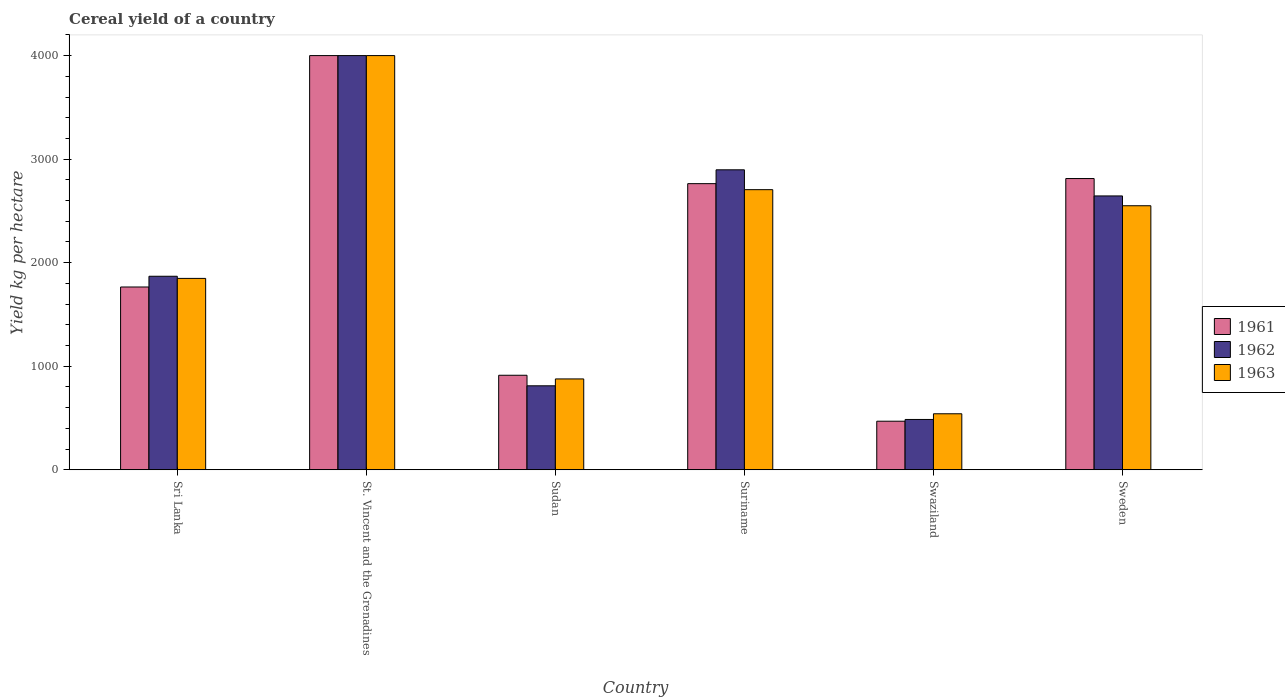How many different coloured bars are there?
Ensure brevity in your answer.  3. Are the number of bars on each tick of the X-axis equal?
Your response must be concise. Yes. How many bars are there on the 1st tick from the left?
Provide a short and direct response. 3. How many bars are there on the 1st tick from the right?
Make the answer very short. 3. What is the label of the 1st group of bars from the left?
Your answer should be compact. Sri Lanka. What is the total cereal yield in 1963 in Sudan?
Your answer should be very brief. 877.56. Across all countries, what is the maximum total cereal yield in 1962?
Provide a short and direct response. 4000. Across all countries, what is the minimum total cereal yield in 1963?
Provide a short and direct response. 541.11. In which country was the total cereal yield in 1962 maximum?
Give a very brief answer. St. Vincent and the Grenadines. In which country was the total cereal yield in 1962 minimum?
Your response must be concise. Swaziland. What is the total total cereal yield in 1961 in the graph?
Your response must be concise. 1.27e+04. What is the difference between the total cereal yield in 1961 in Sri Lanka and that in Suriname?
Offer a terse response. -997.93. What is the difference between the total cereal yield in 1963 in Sudan and the total cereal yield in 1962 in Sweden?
Your answer should be very brief. -1767.12. What is the average total cereal yield in 1963 per country?
Offer a terse response. 2087.06. What is the difference between the total cereal yield of/in 1961 and total cereal yield of/in 1962 in Suriname?
Ensure brevity in your answer.  -133.64. In how many countries, is the total cereal yield in 1961 greater than 3200 kg per hectare?
Ensure brevity in your answer.  1. What is the ratio of the total cereal yield in 1961 in Sri Lanka to that in Suriname?
Your answer should be very brief. 0.64. What is the difference between the highest and the second highest total cereal yield in 1963?
Ensure brevity in your answer.  1294.69. What is the difference between the highest and the lowest total cereal yield in 1963?
Offer a terse response. 3458.89. In how many countries, is the total cereal yield in 1963 greater than the average total cereal yield in 1963 taken over all countries?
Your response must be concise. 3. What does the 3rd bar from the right in Sweden represents?
Keep it short and to the point. 1961. Are the values on the major ticks of Y-axis written in scientific E-notation?
Ensure brevity in your answer.  No. Does the graph contain any zero values?
Your answer should be very brief. No. How many legend labels are there?
Provide a short and direct response. 3. What is the title of the graph?
Your answer should be very brief. Cereal yield of a country. Does "1964" appear as one of the legend labels in the graph?
Ensure brevity in your answer.  No. What is the label or title of the X-axis?
Provide a succinct answer. Country. What is the label or title of the Y-axis?
Offer a terse response. Yield kg per hectare. What is the Yield kg per hectare in 1961 in Sri Lanka?
Provide a succinct answer. 1765.43. What is the Yield kg per hectare of 1962 in Sri Lanka?
Make the answer very short. 1869.1. What is the Yield kg per hectare of 1963 in Sri Lanka?
Offer a terse response. 1848.43. What is the Yield kg per hectare in 1961 in St. Vincent and the Grenadines?
Make the answer very short. 4000. What is the Yield kg per hectare in 1962 in St. Vincent and the Grenadines?
Provide a succinct answer. 4000. What is the Yield kg per hectare in 1963 in St. Vincent and the Grenadines?
Your answer should be compact. 4000. What is the Yield kg per hectare in 1961 in Sudan?
Make the answer very short. 913.1. What is the Yield kg per hectare of 1962 in Sudan?
Your response must be concise. 811.23. What is the Yield kg per hectare of 1963 in Sudan?
Ensure brevity in your answer.  877.56. What is the Yield kg per hectare of 1961 in Suriname?
Make the answer very short. 2763.36. What is the Yield kg per hectare of 1962 in Suriname?
Make the answer very short. 2897.01. What is the Yield kg per hectare in 1963 in Suriname?
Provide a succinct answer. 2705.31. What is the Yield kg per hectare in 1961 in Swaziland?
Provide a succinct answer. 469.25. What is the Yield kg per hectare in 1962 in Swaziland?
Provide a short and direct response. 486.15. What is the Yield kg per hectare of 1963 in Swaziland?
Keep it short and to the point. 541.11. What is the Yield kg per hectare in 1961 in Sweden?
Provide a succinct answer. 2812.7. What is the Yield kg per hectare of 1962 in Sweden?
Give a very brief answer. 2644.68. What is the Yield kg per hectare of 1963 in Sweden?
Make the answer very short. 2549.97. Across all countries, what is the maximum Yield kg per hectare of 1961?
Provide a succinct answer. 4000. Across all countries, what is the maximum Yield kg per hectare in 1962?
Make the answer very short. 4000. Across all countries, what is the maximum Yield kg per hectare in 1963?
Offer a very short reply. 4000. Across all countries, what is the minimum Yield kg per hectare of 1961?
Give a very brief answer. 469.25. Across all countries, what is the minimum Yield kg per hectare in 1962?
Keep it short and to the point. 486.15. Across all countries, what is the minimum Yield kg per hectare of 1963?
Ensure brevity in your answer.  541.11. What is the total Yield kg per hectare in 1961 in the graph?
Offer a terse response. 1.27e+04. What is the total Yield kg per hectare of 1962 in the graph?
Give a very brief answer. 1.27e+04. What is the total Yield kg per hectare in 1963 in the graph?
Your answer should be compact. 1.25e+04. What is the difference between the Yield kg per hectare of 1961 in Sri Lanka and that in St. Vincent and the Grenadines?
Keep it short and to the point. -2234.57. What is the difference between the Yield kg per hectare of 1962 in Sri Lanka and that in St. Vincent and the Grenadines?
Ensure brevity in your answer.  -2130.9. What is the difference between the Yield kg per hectare in 1963 in Sri Lanka and that in St. Vincent and the Grenadines?
Provide a succinct answer. -2151.57. What is the difference between the Yield kg per hectare of 1961 in Sri Lanka and that in Sudan?
Provide a succinct answer. 852.33. What is the difference between the Yield kg per hectare in 1962 in Sri Lanka and that in Sudan?
Keep it short and to the point. 1057.88. What is the difference between the Yield kg per hectare of 1963 in Sri Lanka and that in Sudan?
Make the answer very short. 970.87. What is the difference between the Yield kg per hectare in 1961 in Sri Lanka and that in Suriname?
Offer a very short reply. -997.93. What is the difference between the Yield kg per hectare in 1962 in Sri Lanka and that in Suriname?
Offer a terse response. -1027.91. What is the difference between the Yield kg per hectare of 1963 in Sri Lanka and that in Suriname?
Your response must be concise. -856.88. What is the difference between the Yield kg per hectare of 1961 in Sri Lanka and that in Swaziland?
Give a very brief answer. 1296.18. What is the difference between the Yield kg per hectare in 1962 in Sri Lanka and that in Swaziland?
Offer a terse response. 1382.95. What is the difference between the Yield kg per hectare in 1963 in Sri Lanka and that in Swaziland?
Make the answer very short. 1307.32. What is the difference between the Yield kg per hectare of 1961 in Sri Lanka and that in Sweden?
Provide a succinct answer. -1047.27. What is the difference between the Yield kg per hectare in 1962 in Sri Lanka and that in Sweden?
Give a very brief answer. -775.58. What is the difference between the Yield kg per hectare in 1963 in Sri Lanka and that in Sweden?
Your response must be concise. -701.54. What is the difference between the Yield kg per hectare in 1961 in St. Vincent and the Grenadines and that in Sudan?
Provide a succinct answer. 3086.9. What is the difference between the Yield kg per hectare of 1962 in St. Vincent and the Grenadines and that in Sudan?
Keep it short and to the point. 3188.78. What is the difference between the Yield kg per hectare in 1963 in St. Vincent and the Grenadines and that in Sudan?
Offer a very short reply. 3122.44. What is the difference between the Yield kg per hectare in 1961 in St. Vincent and the Grenadines and that in Suriname?
Offer a terse response. 1236.64. What is the difference between the Yield kg per hectare in 1962 in St. Vincent and the Grenadines and that in Suriname?
Your answer should be compact. 1102.99. What is the difference between the Yield kg per hectare in 1963 in St. Vincent and the Grenadines and that in Suriname?
Give a very brief answer. 1294.69. What is the difference between the Yield kg per hectare in 1961 in St. Vincent and the Grenadines and that in Swaziland?
Your response must be concise. 3530.75. What is the difference between the Yield kg per hectare in 1962 in St. Vincent and the Grenadines and that in Swaziland?
Your answer should be very brief. 3513.85. What is the difference between the Yield kg per hectare of 1963 in St. Vincent and the Grenadines and that in Swaziland?
Your answer should be compact. 3458.89. What is the difference between the Yield kg per hectare in 1961 in St. Vincent and the Grenadines and that in Sweden?
Make the answer very short. 1187.31. What is the difference between the Yield kg per hectare in 1962 in St. Vincent and the Grenadines and that in Sweden?
Your answer should be compact. 1355.32. What is the difference between the Yield kg per hectare in 1963 in St. Vincent and the Grenadines and that in Sweden?
Keep it short and to the point. 1450.03. What is the difference between the Yield kg per hectare in 1961 in Sudan and that in Suriname?
Provide a short and direct response. -1850.27. What is the difference between the Yield kg per hectare of 1962 in Sudan and that in Suriname?
Provide a short and direct response. -2085.78. What is the difference between the Yield kg per hectare of 1963 in Sudan and that in Suriname?
Make the answer very short. -1827.75. What is the difference between the Yield kg per hectare of 1961 in Sudan and that in Swaziland?
Provide a succinct answer. 443.84. What is the difference between the Yield kg per hectare of 1962 in Sudan and that in Swaziland?
Offer a very short reply. 325.08. What is the difference between the Yield kg per hectare in 1963 in Sudan and that in Swaziland?
Provide a succinct answer. 336.45. What is the difference between the Yield kg per hectare of 1961 in Sudan and that in Sweden?
Your answer should be compact. -1899.6. What is the difference between the Yield kg per hectare of 1962 in Sudan and that in Sweden?
Make the answer very short. -1833.45. What is the difference between the Yield kg per hectare of 1963 in Sudan and that in Sweden?
Make the answer very short. -1672.41. What is the difference between the Yield kg per hectare in 1961 in Suriname and that in Swaziland?
Make the answer very short. 2294.11. What is the difference between the Yield kg per hectare of 1962 in Suriname and that in Swaziland?
Your answer should be very brief. 2410.86. What is the difference between the Yield kg per hectare of 1963 in Suriname and that in Swaziland?
Offer a terse response. 2164.2. What is the difference between the Yield kg per hectare in 1961 in Suriname and that in Sweden?
Ensure brevity in your answer.  -49.33. What is the difference between the Yield kg per hectare in 1962 in Suriname and that in Sweden?
Your answer should be compact. 252.33. What is the difference between the Yield kg per hectare of 1963 in Suriname and that in Sweden?
Your response must be concise. 155.34. What is the difference between the Yield kg per hectare in 1961 in Swaziland and that in Sweden?
Offer a very short reply. -2343.44. What is the difference between the Yield kg per hectare of 1962 in Swaziland and that in Sweden?
Provide a short and direct response. -2158.53. What is the difference between the Yield kg per hectare in 1963 in Swaziland and that in Sweden?
Keep it short and to the point. -2008.86. What is the difference between the Yield kg per hectare in 1961 in Sri Lanka and the Yield kg per hectare in 1962 in St. Vincent and the Grenadines?
Give a very brief answer. -2234.57. What is the difference between the Yield kg per hectare in 1961 in Sri Lanka and the Yield kg per hectare in 1963 in St. Vincent and the Grenadines?
Offer a very short reply. -2234.57. What is the difference between the Yield kg per hectare in 1962 in Sri Lanka and the Yield kg per hectare in 1963 in St. Vincent and the Grenadines?
Offer a terse response. -2130.9. What is the difference between the Yield kg per hectare in 1961 in Sri Lanka and the Yield kg per hectare in 1962 in Sudan?
Keep it short and to the point. 954.2. What is the difference between the Yield kg per hectare of 1961 in Sri Lanka and the Yield kg per hectare of 1963 in Sudan?
Your answer should be compact. 887.87. What is the difference between the Yield kg per hectare of 1962 in Sri Lanka and the Yield kg per hectare of 1963 in Sudan?
Provide a short and direct response. 991.54. What is the difference between the Yield kg per hectare of 1961 in Sri Lanka and the Yield kg per hectare of 1962 in Suriname?
Offer a terse response. -1131.58. What is the difference between the Yield kg per hectare in 1961 in Sri Lanka and the Yield kg per hectare in 1963 in Suriname?
Provide a short and direct response. -939.88. What is the difference between the Yield kg per hectare in 1962 in Sri Lanka and the Yield kg per hectare in 1963 in Suriname?
Keep it short and to the point. -836.21. What is the difference between the Yield kg per hectare of 1961 in Sri Lanka and the Yield kg per hectare of 1962 in Swaziland?
Provide a succinct answer. 1279.28. What is the difference between the Yield kg per hectare in 1961 in Sri Lanka and the Yield kg per hectare in 1963 in Swaziland?
Provide a succinct answer. 1224.32. What is the difference between the Yield kg per hectare in 1962 in Sri Lanka and the Yield kg per hectare in 1963 in Swaziland?
Your answer should be very brief. 1327.99. What is the difference between the Yield kg per hectare in 1961 in Sri Lanka and the Yield kg per hectare in 1962 in Sweden?
Provide a succinct answer. -879.25. What is the difference between the Yield kg per hectare in 1961 in Sri Lanka and the Yield kg per hectare in 1963 in Sweden?
Your answer should be very brief. -784.54. What is the difference between the Yield kg per hectare of 1962 in Sri Lanka and the Yield kg per hectare of 1963 in Sweden?
Offer a terse response. -680.87. What is the difference between the Yield kg per hectare of 1961 in St. Vincent and the Grenadines and the Yield kg per hectare of 1962 in Sudan?
Your answer should be very brief. 3188.78. What is the difference between the Yield kg per hectare of 1961 in St. Vincent and the Grenadines and the Yield kg per hectare of 1963 in Sudan?
Your answer should be compact. 3122.44. What is the difference between the Yield kg per hectare in 1962 in St. Vincent and the Grenadines and the Yield kg per hectare in 1963 in Sudan?
Offer a terse response. 3122.44. What is the difference between the Yield kg per hectare in 1961 in St. Vincent and the Grenadines and the Yield kg per hectare in 1962 in Suriname?
Provide a succinct answer. 1102.99. What is the difference between the Yield kg per hectare of 1961 in St. Vincent and the Grenadines and the Yield kg per hectare of 1963 in Suriname?
Ensure brevity in your answer.  1294.69. What is the difference between the Yield kg per hectare in 1962 in St. Vincent and the Grenadines and the Yield kg per hectare in 1963 in Suriname?
Provide a short and direct response. 1294.69. What is the difference between the Yield kg per hectare of 1961 in St. Vincent and the Grenadines and the Yield kg per hectare of 1962 in Swaziland?
Offer a terse response. 3513.85. What is the difference between the Yield kg per hectare in 1961 in St. Vincent and the Grenadines and the Yield kg per hectare in 1963 in Swaziland?
Provide a short and direct response. 3458.89. What is the difference between the Yield kg per hectare of 1962 in St. Vincent and the Grenadines and the Yield kg per hectare of 1963 in Swaziland?
Give a very brief answer. 3458.89. What is the difference between the Yield kg per hectare in 1961 in St. Vincent and the Grenadines and the Yield kg per hectare in 1962 in Sweden?
Your answer should be compact. 1355.32. What is the difference between the Yield kg per hectare in 1961 in St. Vincent and the Grenadines and the Yield kg per hectare in 1963 in Sweden?
Your answer should be compact. 1450.03. What is the difference between the Yield kg per hectare in 1962 in St. Vincent and the Grenadines and the Yield kg per hectare in 1963 in Sweden?
Your answer should be compact. 1450.03. What is the difference between the Yield kg per hectare of 1961 in Sudan and the Yield kg per hectare of 1962 in Suriname?
Offer a terse response. -1983.91. What is the difference between the Yield kg per hectare of 1961 in Sudan and the Yield kg per hectare of 1963 in Suriname?
Ensure brevity in your answer.  -1792.21. What is the difference between the Yield kg per hectare of 1962 in Sudan and the Yield kg per hectare of 1963 in Suriname?
Make the answer very short. -1894.09. What is the difference between the Yield kg per hectare in 1961 in Sudan and the Yield kg per hectare in 1962 in Swaziland?
Provide a short and direct response. 426.95. What is the difference between the Yield kg per hectare of 1961 in Sudan and the Yield kg per hectare of 1963 in Swaziland?
Your response must be concise. 371.98. What is the difference between the Yield kg per hectare of 1962 in Sudan and the Yield kg per hectare of 1963 in Swaziland?
Your response must be concise. 270.11. What is the difference between the Yield kg per hectare of 1961 in Sudan and the Yield kg per hectare of 1962 in Sweden?
Your answer should be compact. -1731.58. What is the difference between the Yield kg per hectare of 1961 in Sudan and the Yield kg per hectare of 1963 in Sweden?
Provide a short and direct response. -1636.88. What is the difference between the Yield kg per hectare of 1962 in Sudan and the Yield kg per hectare of 1963 in Sweden?
Your response must be concise. -1738.75. What is the difference between the Yield kg per hectare of 1961 in Suriname and the Yield kg per hectare of 1962 in Swaziland?
Give a very brief answer. 2277.22. What is the difference between the Yield kg per hectare in 1961 in Suriname and the Yield kg per hectare in 1963 in Swaziland?
Provide a short and direct response. 2222.25. What is the difference between the Yield kg per hectare in 1962 in Suriname and the Yield kg per hectare in 1963 in Swaziland?
Your response must be concise. 2355.89. What is the difference between the Yield kg per hectare of 1961 in Suriname and the Yield kg per hectare of 1962 in Sweden?
Offer a terse response. 118.69. What is the difference between the Yield kg per hectare in 1961 in Suriname and the Yield kg per hectare in 1963 in Sweden?
Provide a short and direct response. 213.39. What is the difference between the Yield kg per hectare of 1962 in Suriname and the Yield kg per hectare of 1963 in Sweden?
Your answer should be very brief. 347.04. What is the difference between the Yield kg per hectare in 1961 in Swaziland and the Yield kg per hectare in 1962 in Sweden?
Provide a short and direct response. -2175.43. What is the difference between the Yield kg per hectare in 1961 in Swaziland and the Yield kg per hectare in 1963 in Sweden?
Keep it short and to the point. -2080.72. What is the difference between the Yield kg per hectare in 1962 in Swaziland and the Yield kg per hectare in 1963 in Sweden?
Provide a succinct answer. -2063.82. What is the average Yield kg per hectare in 1961 per country?
Your answer should be compact. 2120.64. What is the average Yield kg per hectare of 1962 per country?
Give a very brief answer. 2118.03. What is the average Yield kg per hectare of 1963 per country?
Make the answer very short. 2087.06. What is the difference between the Yield kg per hectare in 1961 and Yield kg per hectare in 1962 in Sri Lanka?
Your response must be concise. -103.67. What is the difference between the Yield kg per hectare of 1961 and Yield kg per hectare of 1963 in Sri Lanka?
Your answer should be very brief. -83. What is the difference between the Yield kg per hectare of 1962 and Yield kg per hectare of 1963 in Sri Lanka?
Your response must be concise. 20.67. What is the difference between the Yield kg per hectare in 1961 and Yield kg per hectare in 1962 in St. Vincent and the Grenadines?
Keep it short and to the point. 0. What is the difference between the Yield kg per hectare of 1961 and Yield kg per hectare of 1963 in St. Vincent and the Grenadines?
Provide a short and direct response. 0. What is the difference between the Yield kg per hectare in 1961 and Yield kg per hectare in 1962 in Sudan?
Provide a short and direct response. 101.87. What is the difference between the Yield kg per hectare in 1961 and Yield kg per hectare in 1963 in Sudan?
Make the answer very short. 35.53. What is the difference between the Yield kg per hectare in 1962 and Yield kg per hectare in 1963 in Sudan?
Provide a succinct answer. -66.34. What is the difference between the Yield kg per hectare of 1961 and Yield kg per hectare of 1962 in Suriname?
Your answer should be compact. -133.64. What is the difference between the Yield kg per hectare in 1961 and Yield kg per hectare in 1963 in Suriname?
Give a very brief answer. 58.05. What is the difference between the Yield kg per hectare of 1962 and Yield kg per hectare of 1963 in Suriname?
Make the answer very short. 191.7. What is the difference between the Yield kg per hectare in 1961 and Yield kg per hectare in 1962 in Swaziland?
Give a very brief answer. -16.9. What is the difference between the Yield kg per hectare in 1961 and Yield kg per hectare in 1963 in Swaziland?
Make the answer very short. -71.86. What is the difference between the Yield kg per hectare of 1962 and Yield kg per hectare of 1963 in Swaziland?
Make the answer very short. -54.97. What is the difference between the Yield kg per hectare in 1961 and Yield kg per hectare in 1962 in Sweden?
Your answer should be compact. 168.02. What is the difference between the Yield kg per hectare of 1961 and Yield kg per hectare of 1963 in Sweden?
Your answer should be compact. 262.72. What is the difference between the Yield kg per hectare in 1962 and Yield kg per hectare in 1963 in Sweden?
Offer a terse response. 94.71. What is the ratio of the Yield kg per hectare in 1961 in Sri Lanka to that in St. Vincent and the Grenadines?
Give a very brief answer. 0.44. What is the ratio of the Yield kg per hectare of 1962 in Sri Lanka to that in St. Vincent and the Grenadines?
Your answer should be very brief. 0.47. What is the ratio of the Yield kg per hectare in 1963 in Sri Lanka to that in St. Vincent and the Grenadines?
Give a very brief answer. 0.46. What is the ratio of the Yield kg per hectare of 1961 in Sri Lanka to that in Sudan?
Keep it short and to the point. 1.93. What is the ratio of the Yield kg per hectare in 1962 in Sri Lanka to that in Sudan?
Make the answer very short. 2.3. What is the ratio of the Yield kg per hectare in 1963 in Sri Lanka to that in Sudan?
Offer a terse response. 2.11. What is the ratio of the Yield kg per hectare in 1961 in Sri Lanka to that in Suriname?
Your answer should be very brief. 0.64. What is the ratio of the Yield kg per hectare of 1962 in Sri Lanka to that in Suriname?
Offer a very short reply. 0.65. What is the ratio of the Yield kg per hectare in 1963 in Sri Lanka to that in Suriname?
Offer a terse response. 0.68. What is the ratio of the Yield kg per hectare in 1961 in Sri Lanka to that in Swaziland?
Your answer should be compact. 3.76. What is the ratio of the Yield kg per hectare in 1962 in Sri Lanka to that in Swaziland?
Offer a very short reply. 3.84. What is the ratio of the Yield kg per hectare of 1963 in Sri Lanka to that in Swaziland?
Provide a short and direct response. 3.42. What is the ratio of the Yield kg per hectare in 1961 in Sri Lanka to that in Sweden?
Your response must be concise. 0.63. What is the ratio of the Yield kg per hectare in 1962 in Sri Lanka to that in Sweden?
Your answer should be very brief. 0.71. What is the ratio of the Yield kg per hectare in 1963 in Sri Lanka to that in Sweden?
Your answer should be compact. 0.72. What is the ratio of the Yield kg per hectare of 1961 in St. Vincent and the Grenadines to that in Sudan?
Offer a terse response. 4.38. What is the ratio of the Yield kg per hectare of 1962 in St. Vincent and the Grenadines to that in Sudan?
Give a very brief answer. 4.93. What is the ratio of the Yield kg per hectare of 1963 in St. Vincent and the Grenadines to that in Sudan?
Give a very brief answer. 4.56. What is the ratio of the Yield kg per hectare of 1961 in St. Vincent and the Grenadines to that in Suriname?
Offer a terse response. 1.45. What is the ratio of the Yield kg per hectare of 1962 in St. Vincent and the Grenadines to that in Suriname?
Provide a short and direct response. 1.38. What is the ratio of the Yield kg per hectare in 1963 in St. Vincent and the Grenadines to that in Suriname?
Your response must be concise. 1.48. What is the ratio of the Yield kg per hectare in 1961 in St. Vincent and the Grenadines to that in Swaziland?
Ensure brevity in your answer.  8.52. What is the ratio of the Yield kg per hectare in 1962 in St. Vincent and the Grenadines to that in Swaziland?
Keep it short and to the point. 8.23. What is the ratio of the Yield kg per hectare of 1963 in St. Vincent and the Grenadines to that in Swaziland?
Keep it short and to the point. 7.39. What is the ratio of the Yield kg per hectare in 1961 in St. Vincent and the Grenadines to that in Sweden?
Give a very brief answer. 1.42. What is the ratio of the Yield kg per hectare in 1962 in St. Vincent and the Grenadines to that in Sweden?
Ensure brevity in your answer.  1.51. What is the ratio of the Yield kg per hectare of 1963 in St. Vincent and the Grenadines to that in Sweden?
Offer a very short reply. 1.57. What is the ratio of the Yield kg per hectare of 1961 in Sudan to that in Suriname?
Offer a very short reply. 0.33. What is the ratio of the Yield kg per hectare in 1962 in Sudan to that in Suriname?
Offer a very short reply. 0.28. What is the ratio of the Yield kg per hectare of 1963 in Sudan to that in Suriname?
Offer a very short reply. 0.32. What is the ratio of the Yield kg per hectare of 1961 in Sudan to that in Swaziland?
Offer a very short reply. 1.95. What is the ratio of the Yield kg per hectare of 1962 in Sudan to that in Swaziland?
Keep it short and to the point. 1.67. What is the ratio of the Yield kg per hectare of 1963 in Sudan to that in Swaziland?
Make the answer very short. 1.62. What is the ratio of the Yield kg per hectare of 1961 in Sudan to that in Sweden?
Ensure brevity in your answer.  0.32. What is the ratio of the Yield kg per hectare in 1962 in Sudan to that in Sweden?
Ensure brevity in your answer.  0.31. What is the ratio of the Yield kg per hectare in 1963 in Sudan to that in Sweden?
Your answer should be very brief. 0.34. What is the ratio of the Yield kg per hectare in 1961 in Suriname to that in Swaziland?
Provide a short and direct response. 5.89. What is the ratio of the Yield kg per hectare of 1962 in Suriname to that in Swaziland?
Keep it short and to the point. 5.96. What is the ratio of the Yield kg per hectare in 1963 in Suriname to that in Swaziland?
Your answer should be very brief. 5. What is the ratio of the Yield kg per hectare in 1961 in Suriname to that in Sweden?
Provide a succinct answer. 0.98. What is the ratio of the Yield kg per hectare of 1962 in Suriname to that in Sweden?
Give a very brief answer. 1.1. What is the ratio of the Yield kg per hectare of 1963 in Suriname to that in Sweden?
Provide a short and direct response. 1.06. What is the ratio of the Yield kg per hectare of 1961 in Swaziland to that in Sweden?
Provide a short and direct response. 0.17. What is the ratio of the Yield kg per hectare of 1962 in Swaziland to that in Sweden?
Provide a succinct answer. 0.18. What is the ratio of the Yield kg per hectare in 1963 in Swaziland to that in Sweden?
Your response must be concise. 0.21. What is the difference between the highest and the second highest Yield kg per hectare of 1961?
Offer a very short reply. 1187.31. What is the difference between the highest and the second highest Yield kg per hectare of 1962?
Keep it short and to the point. 1102.99. What is the difference between the highest and the second highest Yield kg per hectare of 1963?
Provide a succinct answer. 1294.69. What is the difference between the highest and the lowest Yield kg per hectare in 1961?
Make the answer very short. 3530.75. What is the difference between the highest and the lowest Yield kg per hectare in 1962?
Offer a very short reply. 3513.85. What is the difference between the highest and the lowest Yield kg per hectare in 1963?
Your answer should be very brief. 3458.89. 